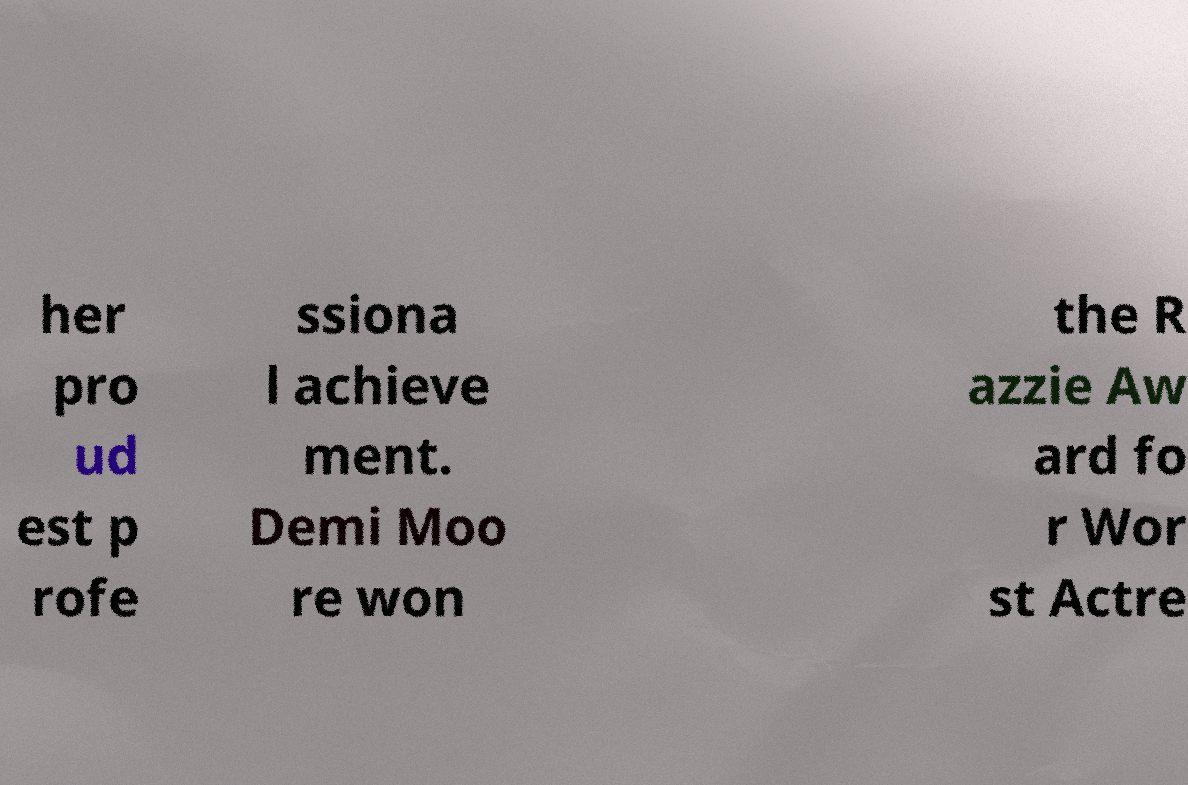Please identify and transcribe the text found in this image. her pro ud est p rofe ssiona l achieve ment. Demi Moo re won the R azzie Aw ard fo r Wor st Actre 